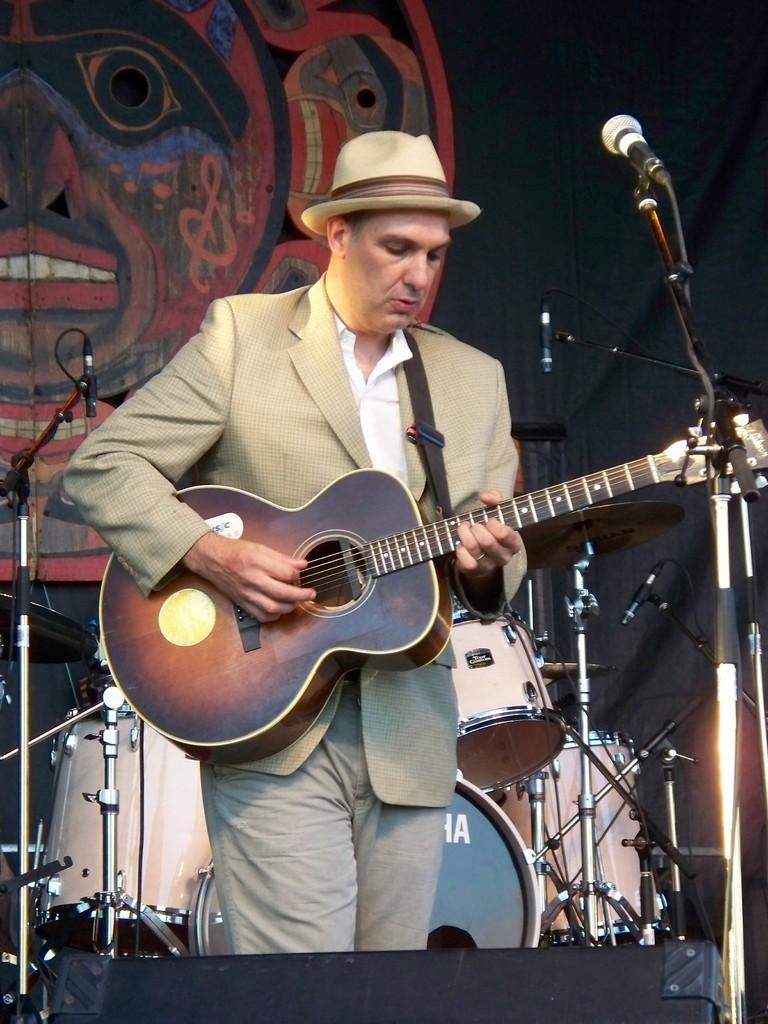Who is the person in the image? There is a man in the image. What is the man wearing? The man is wearing a suit and trousers. What is the man doing in the image? The man is playing a guitar. What other musical instruments can be seen in the background of the image? There are drums and mic stands in the background of the image. What type of cherry is the man using to play the guitar in the image? There is no cherry present in the image, and the man is using his hands to play the guitar. 